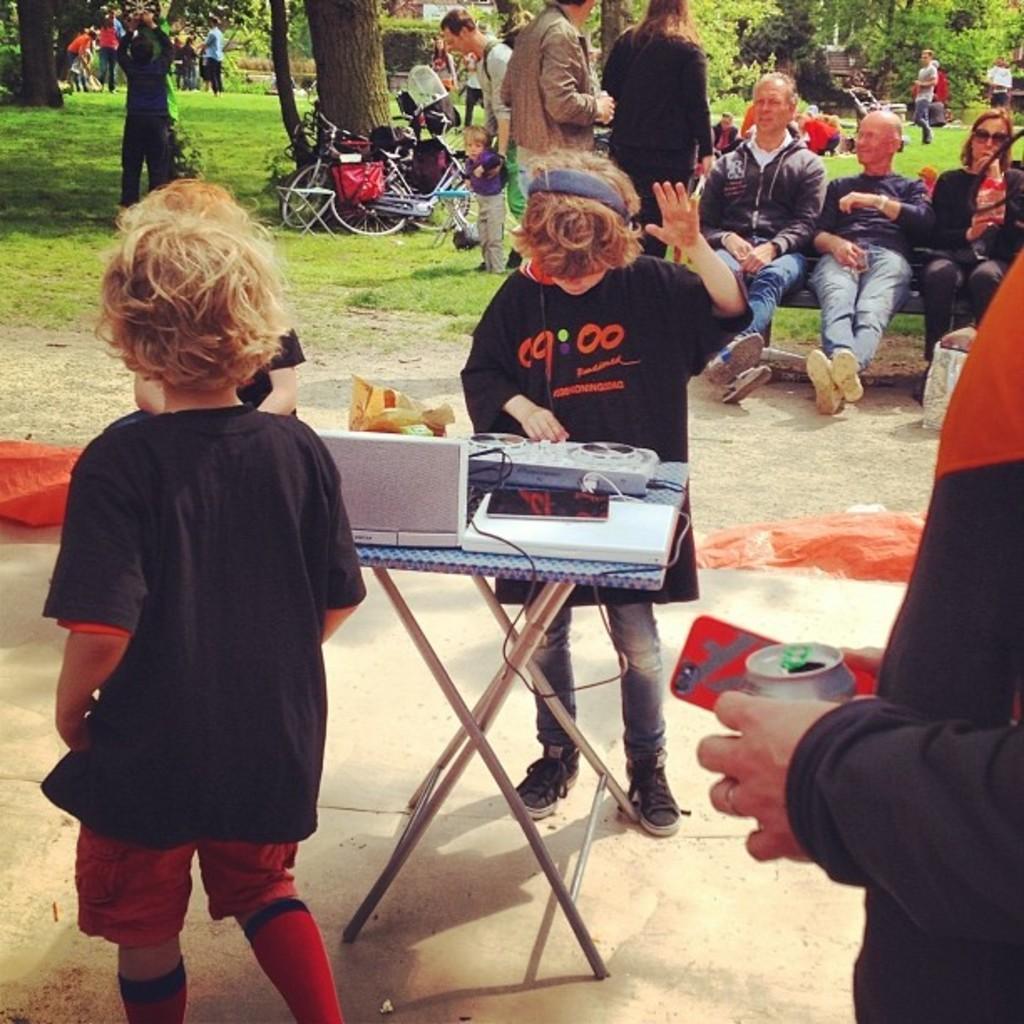Could you give a brief overview of what you see in this image? In the foreground of the picture there are kids, music control system, table, cable, covers and a person holding mobile and tin. In the center of the picture there are bicycles, people, bench, grass and soil. In the background there are trees, people, grass and other objects. 